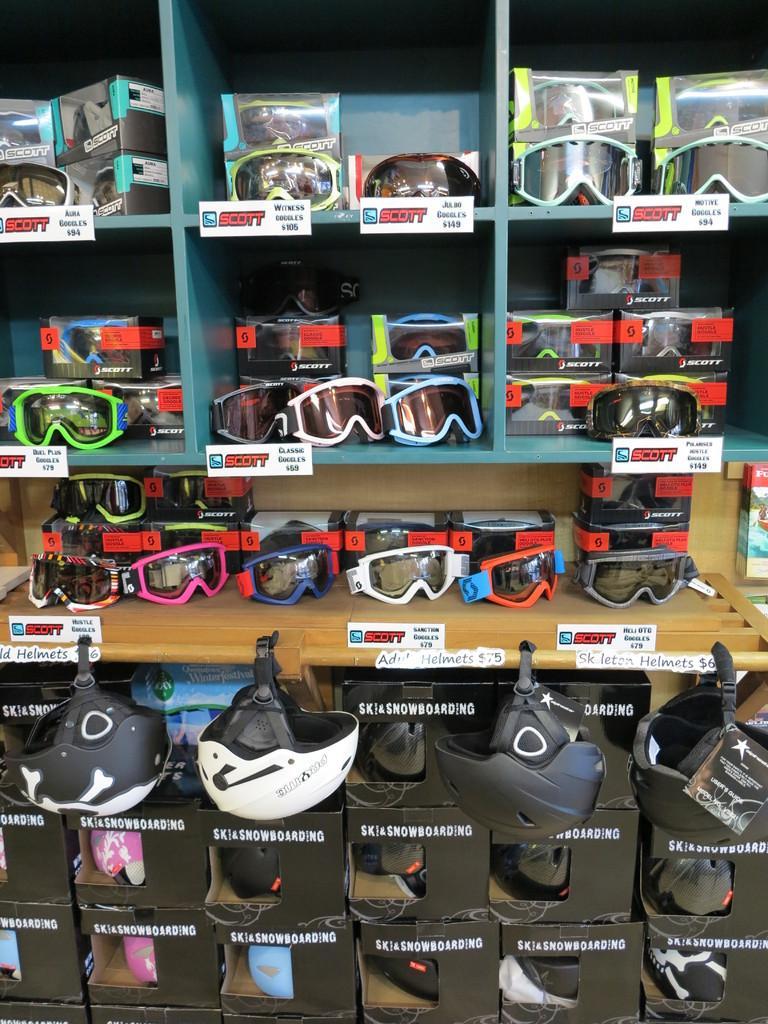Can you describe this image briefly? In this image, we can see a wall shelf and tables contains some goggles. There are helmets at the bottom of the image. 